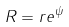Convert formula to latex. <formula><loc_0><loc_0><loc_500><loc_500>R = r e ^ { \psi }</formula> 